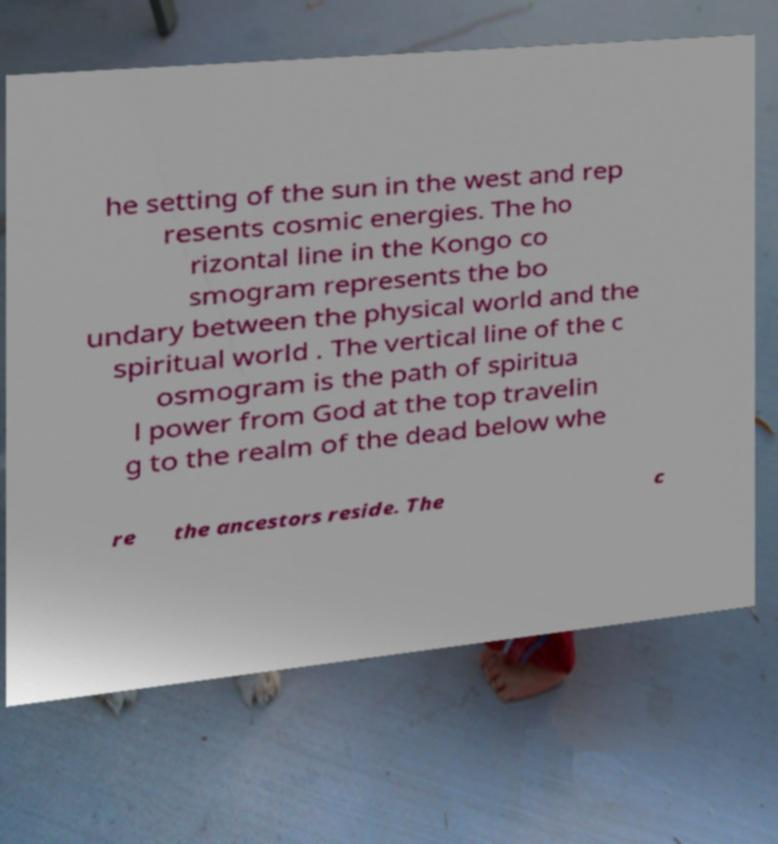Please read and relay the text visible in this image. What does it say? he setting of the sun in the west and rep resents cosmic energies. The ho rizontal line in the Kongo co smogram represents the bo undary between the physical world and the spiritual world . The vertical line of the c osmogram is the path of spiritua l power from God at the top travelin g to the realm of the dead below whe re the ancestors reside. The c 